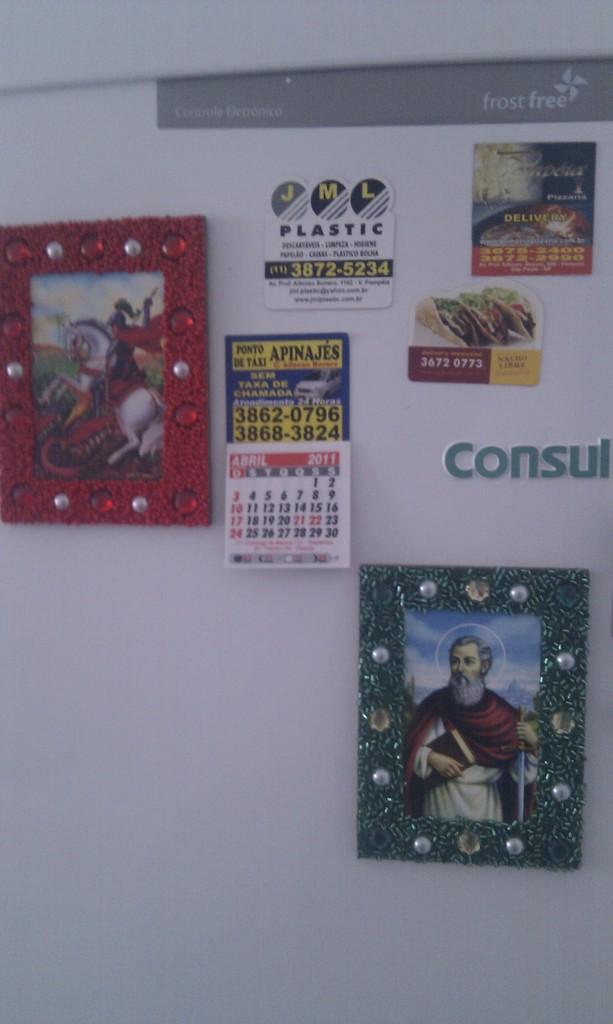What month is shown on the little calendar?
Your answer should be very brief. April. This home calander?
Provide a short and direct response. Yes. 